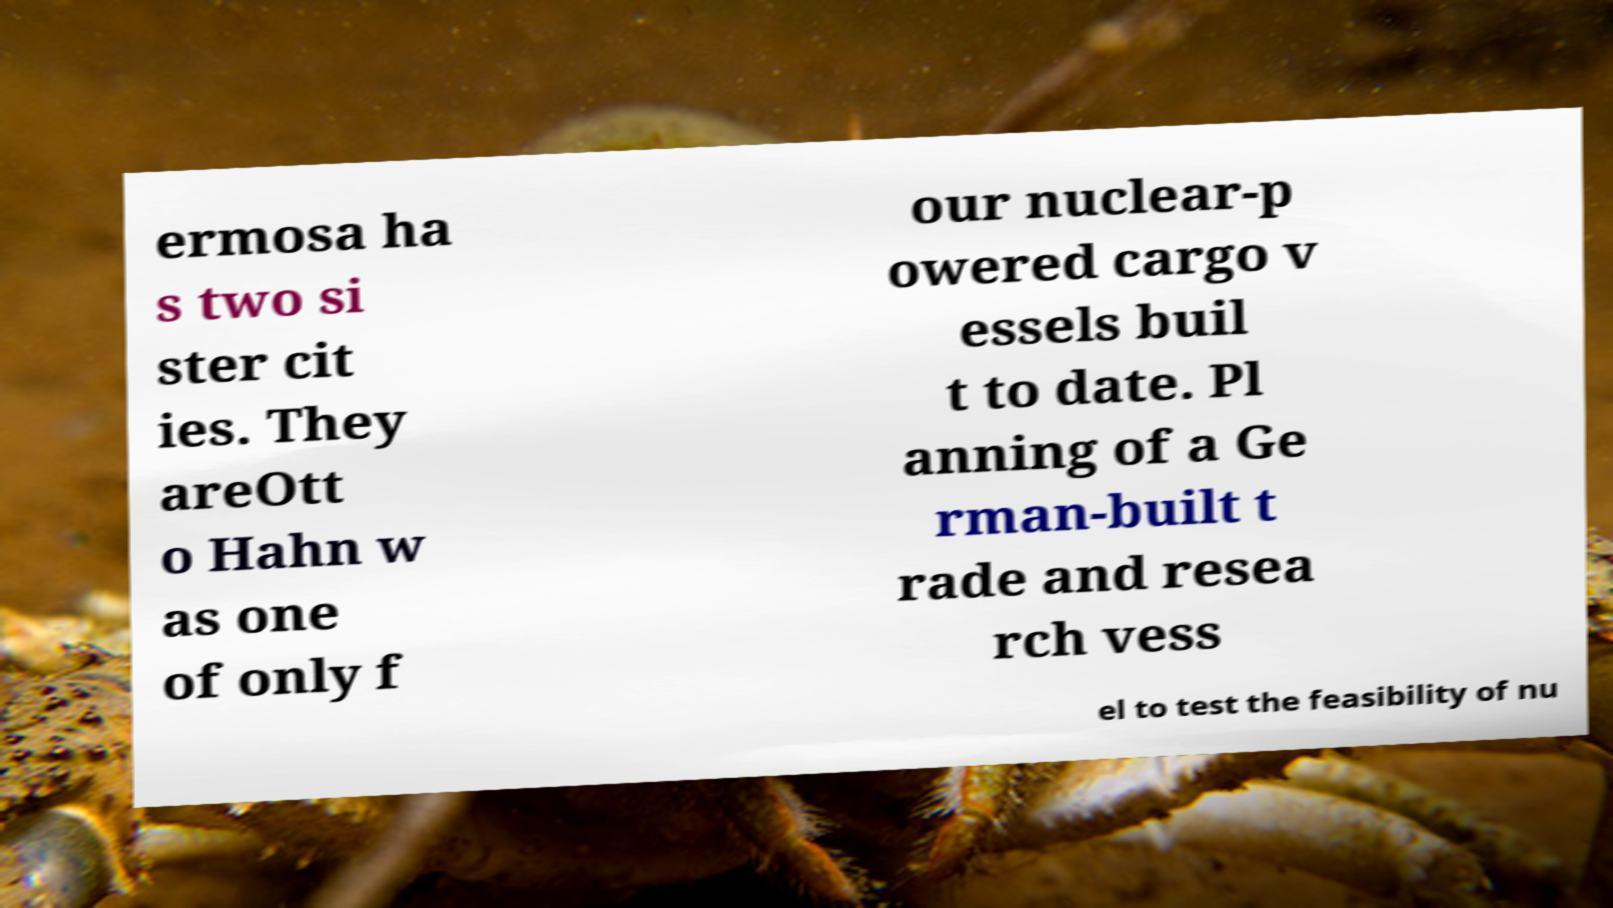Please identify and transcribe the text found in this image. ermosa ha s two si ster cit ies. They areOtt o Hahn w as one of only f our nuclear-p owered cargo v essels buil t to date. Pl anning of a Ge rman-built t rade and resea rch vess el to test the feasibility of nu 